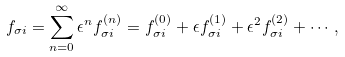<formula> <loc_0><loc_0><loc_500><loc_500>f _ { \sigma i } = \sum _ { n = 0 } ^ { \infty } \epsilon ^ { n } f _ { \sigma i } ^ { ( n ) } = f _ { \sigma i } ^ { ( 0 ) } + \epsilon f _ { \sigma i } ^ { ( 1 ) } + \epsilon ^ { 2 } f _ { \sigma i } ^ { ( 2 ) } + \cdots ,</formula> 